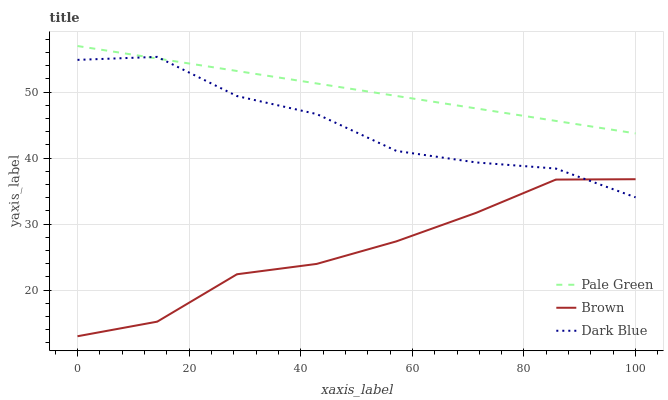Does Brown have the minimum area under the curve?
Answer yes or no. Yes. Does Dark Blue have the minimum area under the curve?
Answer yes or no. No. Does Dark Blue have the maximum area under the curve?
Answer yes or no. No. Is Dark Blue the smoothest?
Answer yes or no. No. Is Pale Green the roughest?
Answer yes or no. No. Does Dark Blue have the lowest value?
Answer yes or no. No. Does Dark Blue have the highest value?
Answer yes or no. No. Is Brown less than Pale Green?
Answer yes or no. Yes. Is Pale Green greater than Brown?
Answer yes or no. Yes. Does Brown intersect Pale Green?
Answer yes or no. No. 